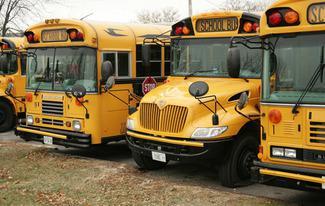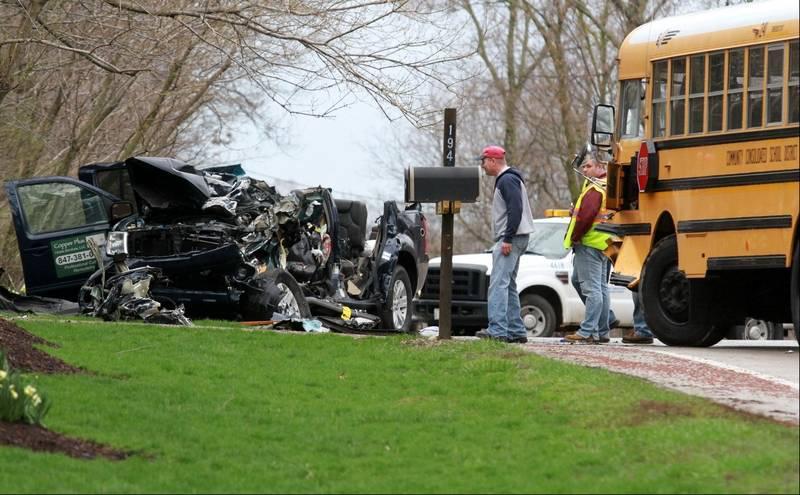The first image is the image on the left, the second image is the image on the right. Given the left and right images, does the statement "An image shows an open bus door viewed head-on, with steps leading inside and the driver seat facing rightward." hold true? Answer yes or no. No. The first image is the image on the left, the second image is the image on the right. Analyze the images presented: Is the assertion "One of the buses' passenger door is open." valid? Answer yes or no. No. 